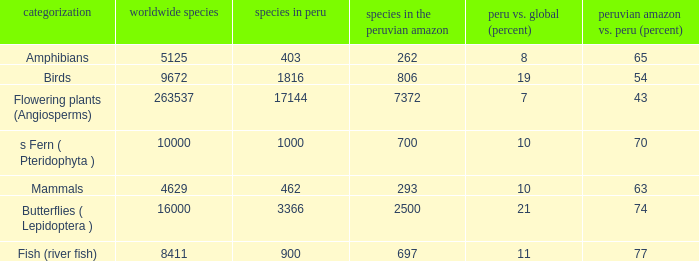What's the minimum species in the peruvian amazon with peru vs. world (percent) value of 7 7372.0. 